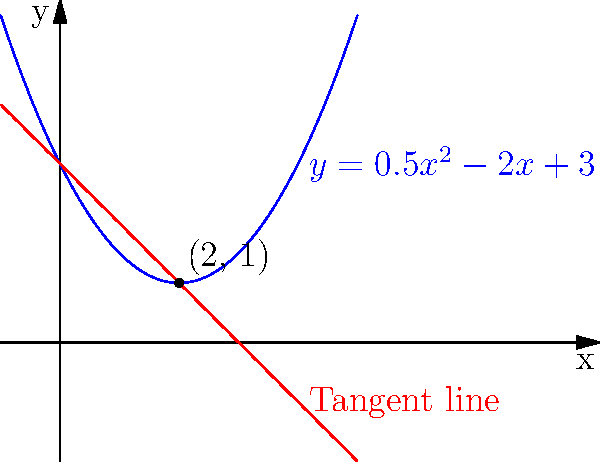Consider the parabola $y = 0.5x^2 - 2x + 3$ and its tangent line at the point (2, 1). Find the equation of the tangent line and determine the x-coordinate of the point where the tangent line intersects the parabola again. 1) First, let's find the equation of the tangent line:
   a) The derivative of $f(x) = 0.5x^2 - 2x + 3$ is $f'(x) = x - 2$
   b) At x = 2, the slope of the tangent line is $f'(2) = 2 - 2 = 0$
   c) Using point-slope form: $y - y_1 = m(x - x_1)$
      $y - 1 = 0(x - 2)$
      $y = 1$

2) The tangent line equation is $y = 1$

3) To find where this line intersects the parabola again, we solve:
   $0.5x^2 - 2x + 3 = 1$
   $0.5x^2 - 2x + 2 = 0$

4) This is a quadratic equation. We can solve it using the quadratic formula:
   $x = \frac{-b \pm \sqrt{b^2 - 4ac}}{2a}$

   Here, $a = 0.5$, $b = -2$, and $c = 2$

5) Plugging into the formula:
   $x = \frac{2 \pm \sqrt{4 - 4(0.5)(2)}}{2(0.5)} = \frac{2 \pm \sqrt{0}}{1} = 2$

6) We get x = 2 twice, which means the tangent line touches the parabola at (2, 1) but doesn't intersect it at any other point.
Answer: The tangent line equation is $y = 1$, and it only touches the parabola at x = 2. 